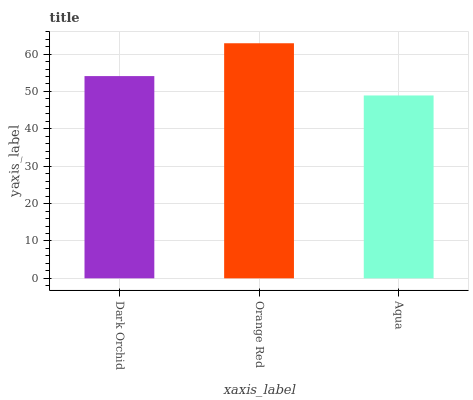Is Orange Red the minimum?
Answer yes or no. No. Is Aqua the maximum?
Answer yes or no. No. Is Orange Red greater than Aqua?
Answer yes or no. Yes. Is Aqua less than Orange Red?
Answer yes or no. Yes. Is Aqua greater than Orange Red?
Answer yes or no. No. Is Orange Red less than Aqua?
Answer yes or no. No. Is Dark Orchid the high median?
Answer yes or no. Yes. Is Dark Orchid the low median?
Answer yes or no. Yes. Is Orange Red the high median?
Answer yes or no. No. Is Aqua the low median?
Answer yes or no. No. 